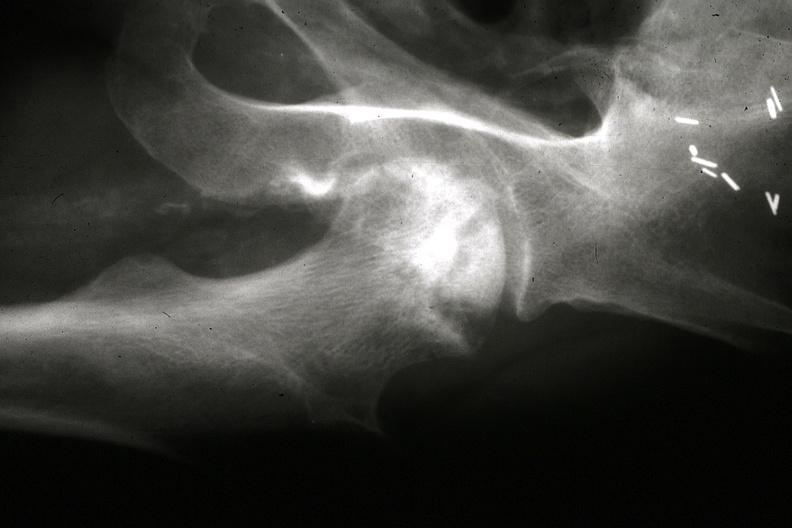what are in slides?
Answer the question using a single word or phrase. Other x-rays 